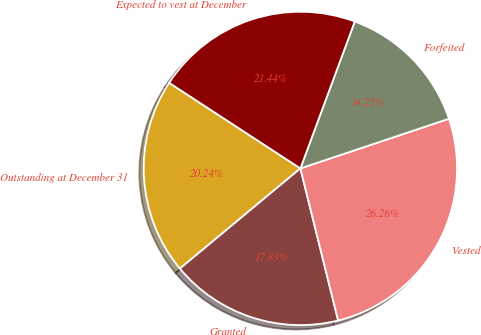Convert chart. <chart><loc_0><loc_0><loc_500><loc_500><pie_chart><fcel>Outstanding at December 31<fcel>Granted<fcel>Vested<fcel>Forfeited<fcel>Expected to vest at December<nl><fcel>20.24%<fcel>17.83%<fcel>26.26%<fcel>14.22%<fcel>21.44%<nl></chart> 